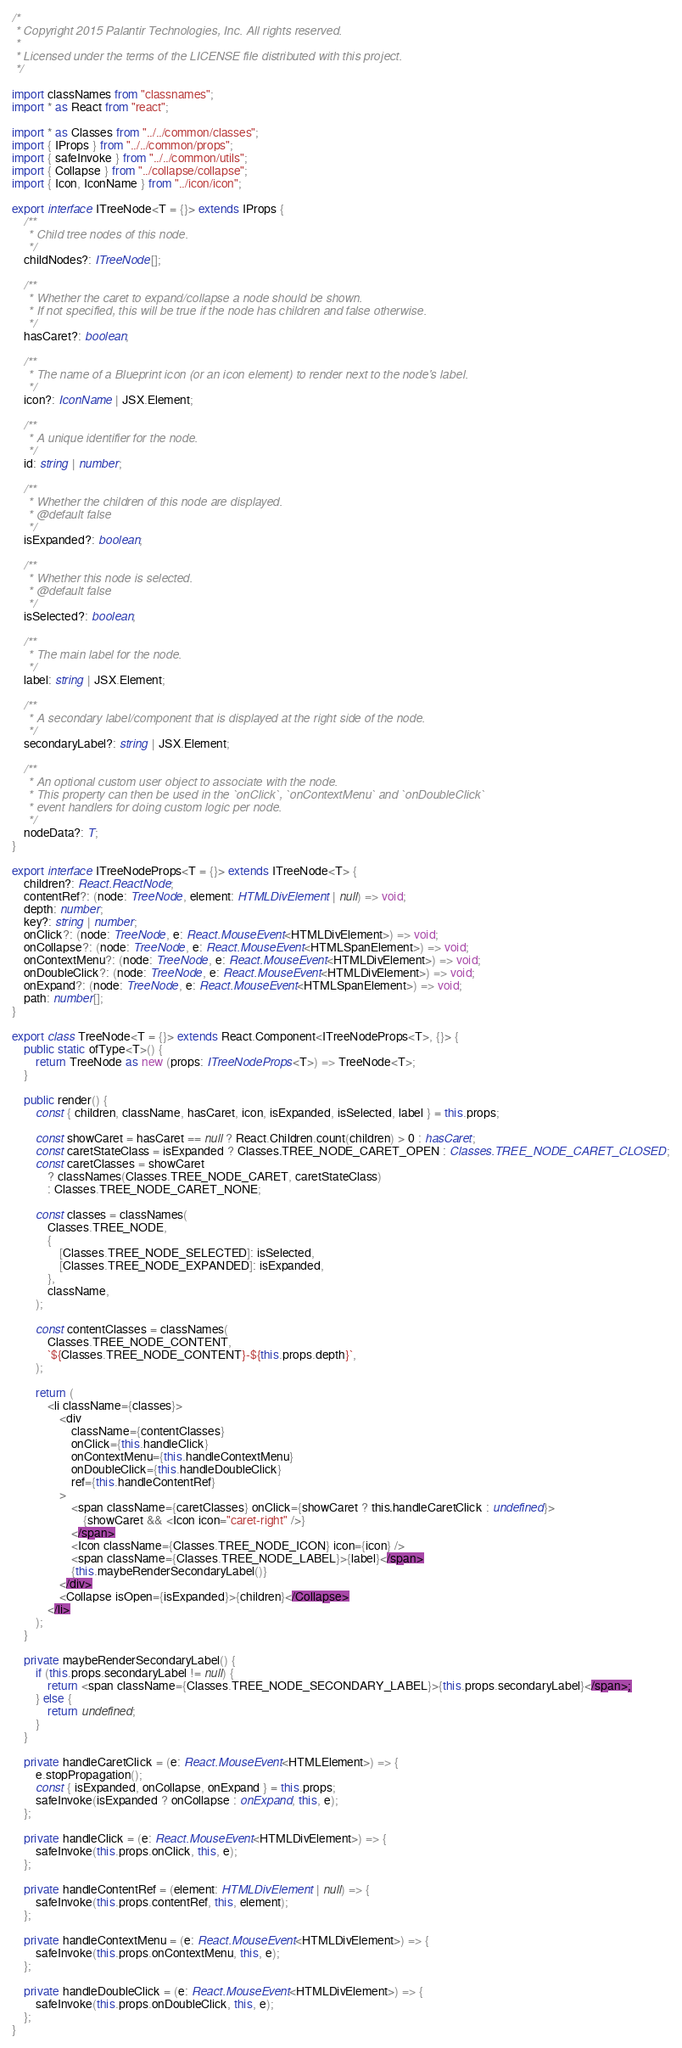<code> <loc_0><loc_0><loc_500><loc_500><_TypeScript_>/*
 * Copyright 2015 Palantir Technologies, Inc. All rights reserved.
 *
 * Licensed under the terms of the LICENSE file distributed with this project.
 */

import classNames from "classnames";
import * as React from "react";

import * as Classes from "../../common/classes";
import { IProps } from "../../common/props";
import { safeInvoke } from "../../common/utils";
import { Collapse } from "../collapse/collapse";
import { Icon, IconName } from "../icon/icon";

export interface ITreeNode<T = {}> extends IProps {
    /**
     * Child tree nodes of this node.
     */
    childNodes?: ITreeNode[];

    /**
     * Whether the caret to expand/collapse a node should be shown.
     * If not specified, this will be true if the node has children and false otherwise.
     */
    hasCaret?: boolean;

    /**
     * The name of a Blueprint icon (or an icon element) to render next to the node's label.
     */
    icon?: IconName | JSX.Element;

    /**
     * A unique identifier for the node.
     */
    id: string | number;

    /**
     * Whether the children of this node are displayed.
     * @default false
     */
    isExpanded?: boolean;

    /**
     * Whether this node is selected.
     * @default false
     */
    isSelected?: boolean;

    /**
     * The main label for the node.
     */
    label: string | JSX.Element;

    /**
     * A secondary label/component that is displayed at the right side of the node.
     */
    secondaryLabel?: string | JSX.Element;

    /**
     * An optional custom user object to associate with the node.
     * This property can then be used in the `onClick`, `onContextMenu` and `onDoubleClick`
     * event handlers for doing custom logic per node.
     */
    nodeData?: T;
}

export interface ITreeNodeProps<T = {}> extends ITreeNode<T> {
    children?: React.ReactNode;
    contentRef?: (node: TreeNode, element: HTMLDivElement | null) => void;
    depth: number;
    key?: string | number;
    onClick?: (node: TreeNode, e: React.MouseEvent<HTMLDivElement>) => void;
    onCollapse?: (node: TreeNode, e: React.MouseEvent<HTMLSpanElement>) => void;
    onContextMenu?: (node: TreeNode, e: React.MouseEvent<HTMLDivElement>) => void;
    onDoubleClick?: (node: TreeNode, e: React.MouseEvent<HTMLDivElement>) => void;
    onExpand?: (node: TreeNode, e: React.MouseEvent<HTMLSpanElement>) => void;
    path: number[];
}

export class TreeNode<T = {}> extends React.Component<ITreeNodeProps<T>, {}> {
    public static ofType<T>() {
        return TreeNode as new (props: ITreeNodeProps<T>) => TreeNode<T>;
    }

    public render() {
        const { children, className, hasCaret, icon, isExpanded, isSelected, label } = this.props;

        const showCaret = hasCaret == null ? React.Children.count(children) > 0 : hasCaret;
        const caretStateClass = isExpanded ? Classes.TREE_NODE_CARET_OPEN : Classes.TREE_NODE_CARET_CLOSED;
        const caretClasses = showCaret
            ? classNames(Classes.TREE_NODE_CARET, caretStateClass)
            : Classes.TREE_NODE_CARET_NONE;

        const classes = classNames(
            Classes.TREE_NODE,
            {
                [Classes.TREE_NODE_SELECTED]: isSelected,
                [Classes.TREE_NODE_EXPANDED]: isExpanded,
            },
            className,
        );

        const contentClasses = classNames(
            Classes.TREE_NODE_CONTENT,
            `${Classes.TREE_NODE_CONTENT}-${this.props.depth}`,
        );

        return (
            <li className={classes}>
                <div
                    className={contentClasses}
                    onClick={this.handleClick}
                    onContextMenu={this.handleContextMenu}
                    onDoubleClick={this.handleDoubleClick}
                    ref={this.handleContentRef}
                >
                    <span className={caretClasses} onClick={showCaret ? this.handleCaretClick : undefined}>
                        {showCaret && <Icon icon="caret-right" />}
                    </span>
                    <Icon className={Classes.TREE_NODE_ICON} icon={icon} />
                    <span className={Classes.TREE_NODE_LABEL}>{label}</span>
                    {this.maybeRenderSecondaryLabel()}
                </div>
                <Collapse isOpen={isExpanded}>{children}</Collapse>
            </li>
        );
    }

    private maybeRenderSecondaryLabel() {
        if (this.props.secondaryLabel != null) {
            return <span className={Classes.TREE_NODE_SECONDARY_LABEL}>{this.props.secondaryLabel}</span>;
        } else {
            return undefined;
        }
    }

    private handleCaretClick = (e: React.MouseEvent<HTMLElement>) => {
        e.stopPropagation();
        const { isExpanded, onCollapse, onExpand } = this.props;
        safeInvoke(isExpanded ? onCollapse : onExpand, this, e);
    };

    private handleClick = (e: React.MouseEvent<HTMLDivElement>) => {
        safeInvoke(this.props.onClick, this, e);
    };

    private handleContentRef = (element: HTMLDivElement | null) => {
        safeInvoke(this.props.contentRef, this, element);
    };

    private handleContextMenu = (e: React.MouseEvent<HTMLDivElement>) => {
        safeInvoke(this.props.onContextMenu, this, e);
    };

    private handleDoubleClick = (e: React.MouseEvent<HTMLDivElement>) => {
        safeInvoke(this.props.onDoubleClick, this, e);
    };
}
</code> 